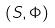<formula> <loc_0><loc_0><loc_500><loc_500>( S , \Phi )</formula> 